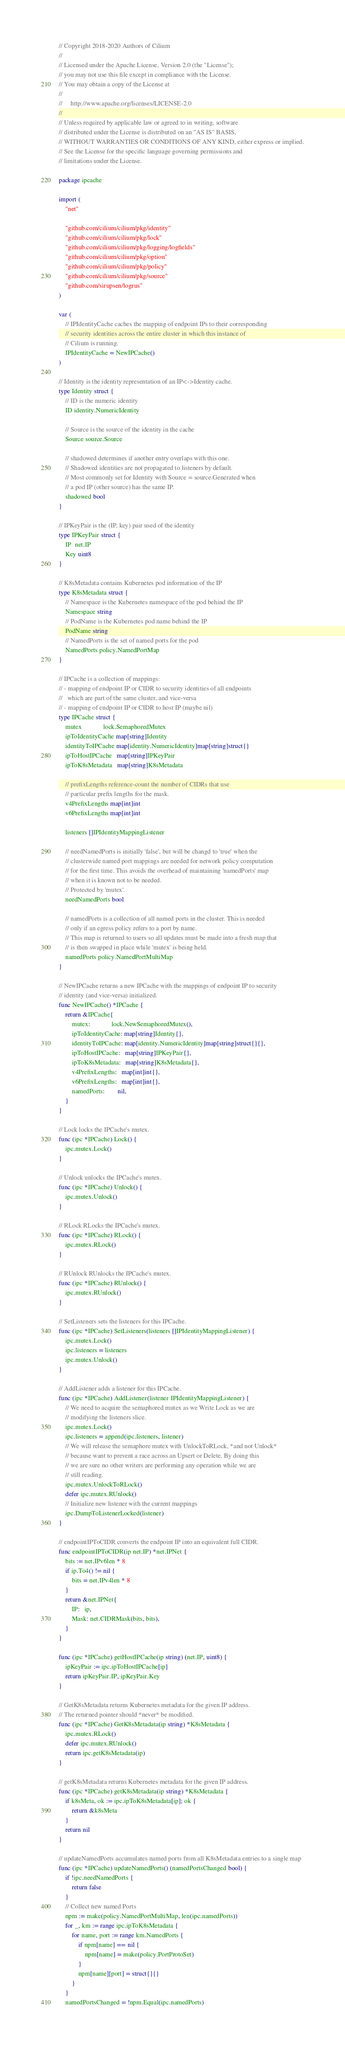Convert code to text. <code><loc_0><loc_0><loc_500><loc_500><_Go_>// Copyright 2018-2020 Authors of Cilium
//
// Licensed under the Apache License, Version 2.0 (the "License");
// you may not use this file except in compliance with the License.
// You may obtain a copy of the License at
//
//     http://www.apache.org/licenses/LICENSE-2.0
//
// Unless required by applicable law or agreed to in writing, software
// distributed under the License is distributed on an "AS IS" BASIS,
// WITHOUT WARRANTIES OR CONDITIONS OF ANY KIND, either express or implied.
// See the License for the specific language governing permissions and
// limitations under the License.

package ipcache

import (
	"net"

	"github.com/cilium/cilium/pkg/identity"
	"github.com/cilium/cilium/pkg/lock"
	"github.com/cilium/cilium/pkg/logging/logfields"
	"github.com/cilium/cilium/pkg/option"
	"github.com/cilium/cilium/pkg/policy"
	"github.com/cilium/cilium/pkg/source"
	"github.com/sirupsen/logrus"
)

var (
	// IPIdentityCache caches the mapping of endpoint IPs to their corresponding
	// security identities across the entire cluster in which this instance of
	// Cilium is running.
	IPIdentityCache = NewIPCache()
)

// Identity is the identity representation of an IP<->Identity cache.
type Identity struct {
	// ID is the numeric identity
	ID identity.NumericIdentity

	// Source is the source of the identity in the cache
	Source source.Source

	// shadowed determines if another entry overlaps with this one.
	// Shadowed identities are not propagated to listeners by default.
	// Most commonly set for Identity with Source = source.Generated when
	// a pod IP (other source) has the same IP.
	shadowed bool
}

// IPKeyPair is the (IP, key) pair used of the identity
type IPKeyPair struct {
	IP  net.IP
	Key uint8
}

// K8sMetadata contains Kubernetes pod information of the IP
type K8sMetadata struct {
	// Namespace is the Kubernetes namespace of the pod behind the IP
	Namespace string
	// PodName is the Kubernetes pod name behind the IP
	PodName string
	// NamedPorts is the set of named ports for the pod
	NamedPorts policy.NamedPortMap
}

// IPCache is a collection of mappings:
// - mapping of endpoint IP or CIDR to security identities of all endpoints
//   which are part of the same cluster, and vice-versa
// - mapping of endpoint IP or CIDR to host IP (maybe nil)
type IPCache struct {
	mutex             lock.SemaphoredMutex
	ipToIdentityCache map[string]Identity
	identityToIPCache map[identity.NumericIdentity]map[string]struct{}
	ipToHostIPCache   map[string]IPKeyPair
	ipToK8sMetadata   map[string]K8sMetadata

	// prefixLengths reference-count the number of CIDRs that use
	// particular prefix lengths for the mask.
	v4PrefixLengths map[int]int
	v6PrefixLengths map[int]int

	listeners []IPIdentityMappingListener

	// needNamedPorts is initially 'false', but will be changd to 'true' when the
	// clusterwide named port mappings are needed for network policy computation
	// for the first time. This avoids the overhead of maintaining 'namedPorts' map
	// when it is known not to be needed.
	// Protected by 'mutex'.
	needNamedPorts bool

	// namedPorts is a collection of all named ports in the cluster. This is needed
	// only if an egress policy refers to a port by name.
	// This map is returned to users so all updates must be made into a fresh map that
	// is then swapped in place while 'mutex' is being held.
	namedPorts policy.NamedPortMultiMap
}

// NewIPCache returns a new IPCache with the mappings of endpoint IP to security
// identity (and vice-versa) initialized.
func NewIPCache() *IPCache {
	return &IPCache{
		mutex:             lock.NewSemaphoredMutex(),
		ipToIdentityCache: map[string]Identity{},
		identityToIPCache: map[identity.NumericIdentity]map[string]struct{}{},
		ipToHostIPCache:   map[string]IPKeyPair{},
		ipToK8sMetadata:   map[string]K8sMetadata{},
		v4PrefixLengths:   map[int]int{},
		v6PrefixLengths:   map[int]int{},
		namedPorts:        nil,
	}
}

// Lock locks the IPCache's mutex.
func (ipc *IPCache) Lock() {
	ipc.mutex.Lock()
}

// Unlock unlocks the IPCache's mutex.
func (ipc *IPCache) Unlock() {
	ipc.mutex.Unlock()
}

// RLock RLocks the IPCache's mutex.
func (ipc *IPCache) RLock() {
	ipc.mutex.RLock()
}

// RUnlock RUnlocks the IPCache's mutex.
func (ipc *IPCache) RUnlock() {
	ipc.mutex.RUnlock()
}

// SetListeners sets the listeners for this IPCache.
func (ipc *IPCache) SetListeners(listeners []IPIdentityMappingListener) {
	ipc.mutex.Lock()
	ipc.listeners = listeners
	ipc.mutex.Unlock()
}

// AddListener adds a listener for this IPCache.
func (ipc *IPCache) AddListener(listener IPIdentityMappingListener) {
	// We need to acquire the semaphored mutex as we Write Lock as we are
	// modifying the listeners slice.
	ipc.mutex.Lock()
	ipc.listeners = append(ipc.listeners, listener)
	// We will release the semaphore mutex with UnlockToRLock, *and not Unlock*
	// because want to prevent a race across an Upsert or Delete. By doing this
	// we are sure no other writers are performing any operation while we are
	// still reading.
	ipc.mutex.UnlockToRLock()
	defer ipc.mutex.RUnlock()
	// Initialize new listener with the current mappings
	ipc.DumpToListenerLocked(listener)
}

// endpointIPToCIDR converts the endpoint IP into an equivalent full CIDR.
func endpointIPToCIDR(ip net.IP) *net.IPNet {
	bits := net.IPv6len * 8
	if ip.To4() != nil {
		bits = net.IPv4len * 8
	}
	return &net.IPNet{
		IP:   ip,
		Mask: net.CIDRMask(bits, bits),
	}
}

func (ipc *IPCache) getHostIPCache(ip string) (net.IP, uint8) {
	ipKeyPair := ipc.ipToHostIPCache[ip]
	return ipKeyPair.IP, ipKeyPair.Key
}

// GetK8sMetadata returns Kubernetes metadata for the given IP address.
// The returned pointer should *never* be modified.
func (ipc *IPCache) GetK8sMetadata(ip string) *K8sMetadata {
	ipc.mutex.RLock()
	defer ipc.mutex.RUnlock()
	return ipc.getK8sMetadata(ip)
}

// getK8sMetadata returns Kubernetes metadata for the given IP address.
func (ipc *IPCache) getK8sMetadata(ip string) *K8sMetadata {
	if k8sMeta, ok := ipc.ipToK8sMetadata[ip]; ok {
		return &k8sMeta
	}
	return nil
}

// updateNamedPorts accumulates named ports from all K8sMetadata entries to a single map
func (ipc *IPCache) updateNamedPorts() (namedPortsChanged bool) {
	if !ipc.needNamedPorts {
		return false
	}
	// Collect new named Ports
	npm := make(policy.NamedPortMultiMap, len(ipc.namedPorts))
	for _, km := range ipc.ipToK8sMetadata {
		for name, port := range km.NamedPorts {
			if npm[name] == nil {
				npm[name] = make(policy.PortProtoSet)
			}
			npm[name][port] = struct{}{}
		}
	}
	namedPortsChanged = !npm.Equal(ipc.namedPorts)</code> 